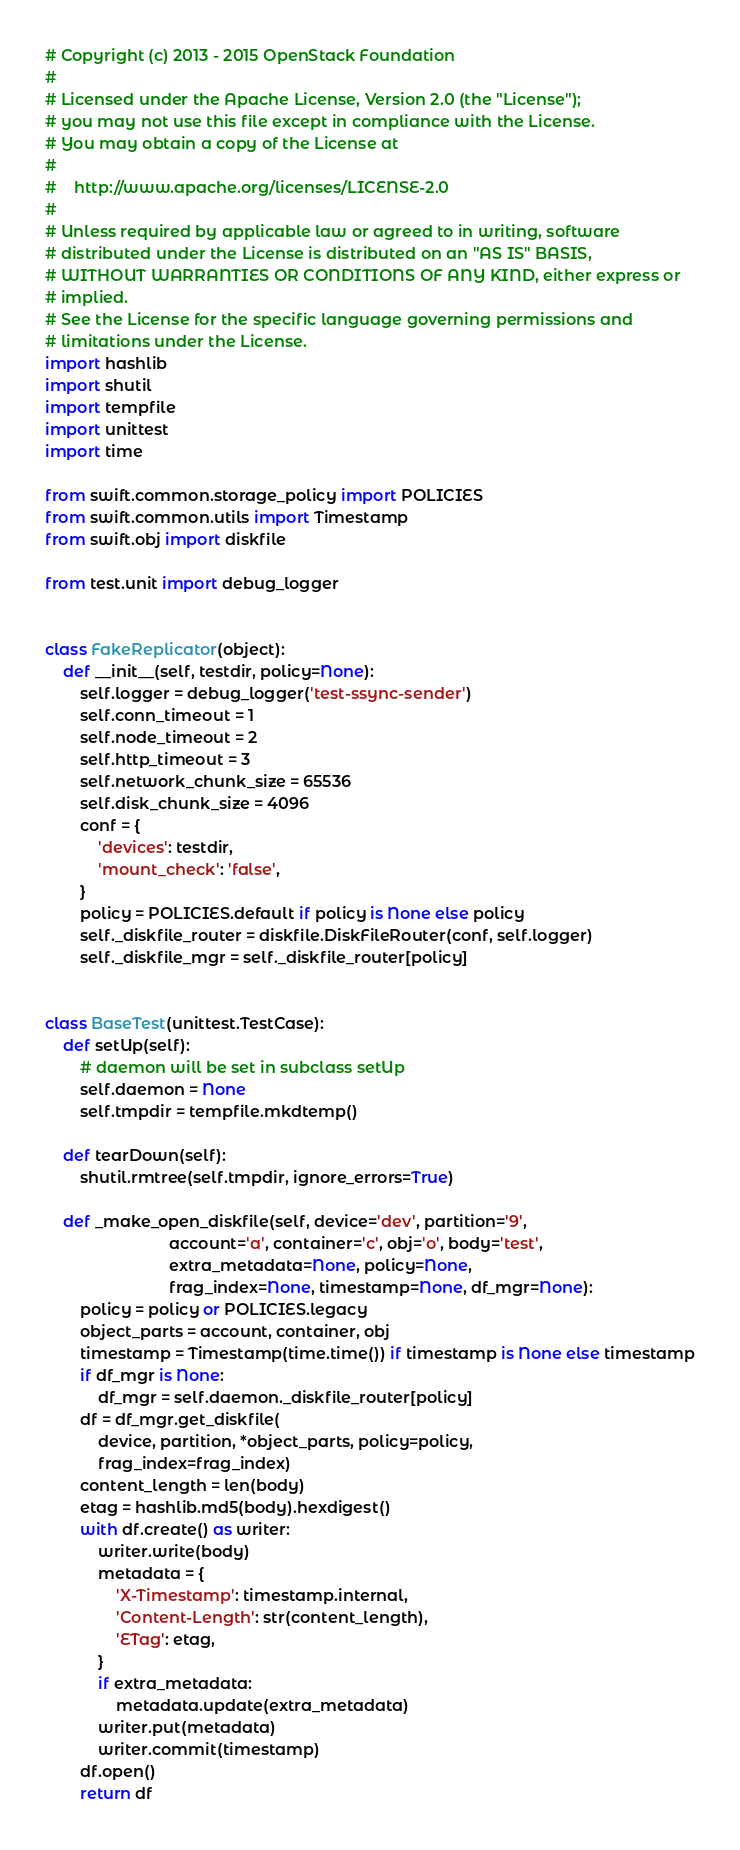<code> <loc_0><loc_0><loc_500><loc_500><_Python_># Copyright (c) 2013 - 2015 OpenStack Foundation
#
# Licensed under the Apache License, Version 2.0 (the "License");
# you may not use this file except in compliance with the License.
# You may obtain a copy of the License at
#
#    http://www.apache.org/licenses/LICENSE-2.0
#
# Unless required by applicable law or agreed to in writing, software
# distributed under the License is distributed on an "AS IS" BASIS,
# WITHOUT WARRANTIES OR CONDITIONS OF ANY KIND, either express or
# implied.
# See the License for the specific language governing permissions and
# limitations under the License.
import hashlib
import shutil
import tempfile
import unittest
import time

from swift.common.storage_policy import POLICIES
from swift.common.utils import Timestamp
from swift.obj import diskfile

from test.unit import debug_logger


class FakeReplicator(object):
    def __init__(self, testdir, policy=None):
        self.logger = debug_logger('test-ssync-sender')
        self.conn_timeout = 1
        self.node_timeout = 2
        self.http_timeout = 3
        self.network_chunk_size = 65536
        self.disk_chunk_size = 4096
        conf = {
            'devices': testdir,
            'mount_check': 'false',
        }
        policy = POLICIES.default if policy is None else policy
        self._diskfile_router = diskfile.DiskFileRouter(conf, self.logger)
        self._diskfile_mgr = self._diskfile_router[policy]


class BaseTest(unittest.TestCase):
    def setUp(self):
        # daemon will be set in subclass setUp
        self.daemon = None
        self.tmpdir = tempfile.mkdtemp()

    def tearDown(self):
        shutil.rmtree(self.tmpdir, ignore_errors=True)

    def _make_open_diskfile(self, device='dev', partition='9',
                            account='a', container='c', obj='o', body='test',
                            extra_metadata=None, policy=None,
                            frag_index=None, timestamp=None, df_mgr=None):
        policy = policy or POLICIES.legacy
        object_parts = account, container, obj
        timestamp = Timestamp(time.time()) if timestamp is None else timestamp
        if df_mgr is None:
            df_mgr = self.daemon._diskfile_router[policy]
        df = df_mgr.get_diskfile(
            device, partition, *object_parts, policy=policy,
            frag_index=frag_index)
        content_length = len(body)
        etag = hashlib.md5(body).hexdigest()
        with df.create() as writer:
            writer.write(body)
            metadata = {
                'X-Timestamp': timestamp.internal,
                'Content-Length': str(content_length),
                'ETag': etag,
            }
            if extra_metadata:
                metadata.update(extra_metadata)
            writer.put(metadata)
            writer.commit(timestamp)
        df.open()
        return df
</code> 